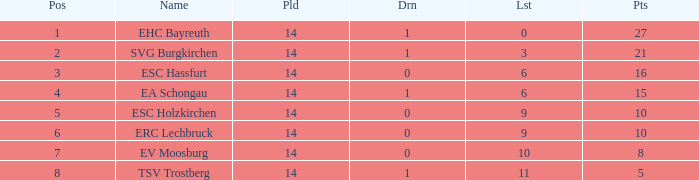What's the points that has a lost more 6, played less than 14 and a position more than 1? None. 